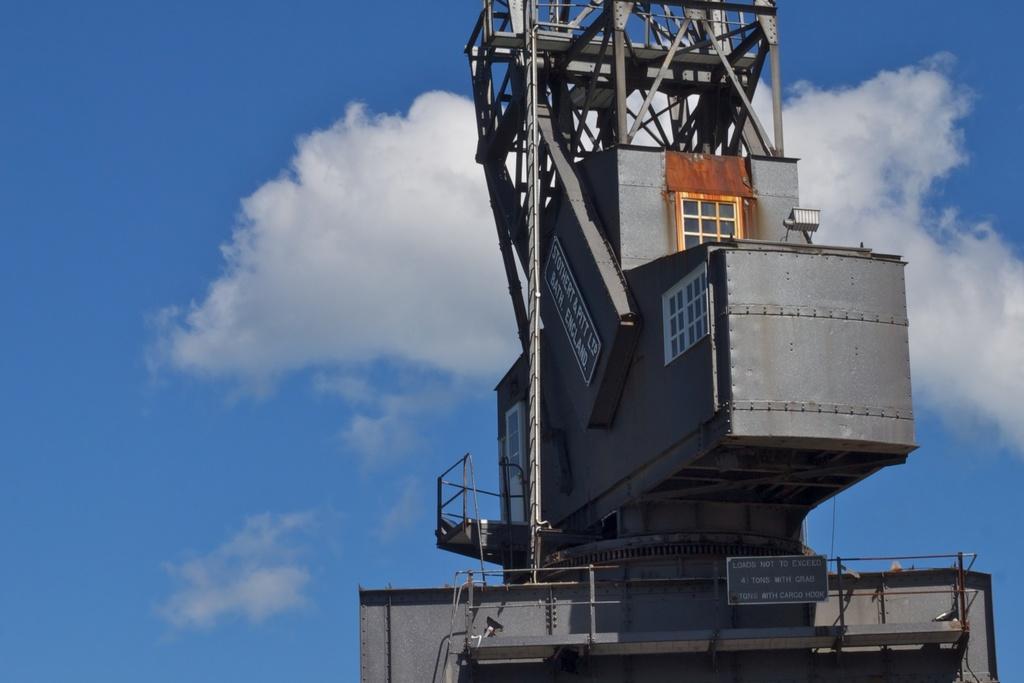Please provide a concise description of this image. In this image I can see the grey color object and I can see the boards attached to it. In the background I can see the clouds and the blue sky. 